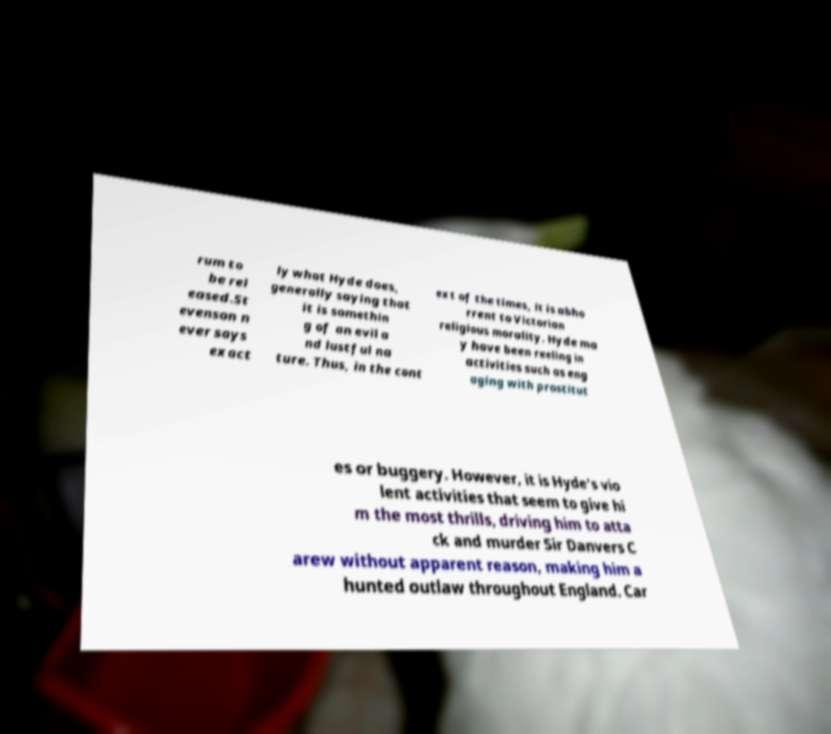There's text embedded in this image that I need extracted. Can you transcribe it verbatim? rum to be rel eased.St evenson n ever says exact ly what Hyde does, generally saying that it is somethin g of an evil a nd lustful na ture. Thus, in the cont ext of the times, it is abho rrent to Victorian religious morality. Hyde ma y have been reeling in activities such as eng aging with prostitut es or buggery. However, it is Hyde's vio lent activities that seem to give hi m the most thrills, driving him to atta ck and murder Sir Danvers C arew without apparent reason, making him a hunted outlaw throughout England. Car 